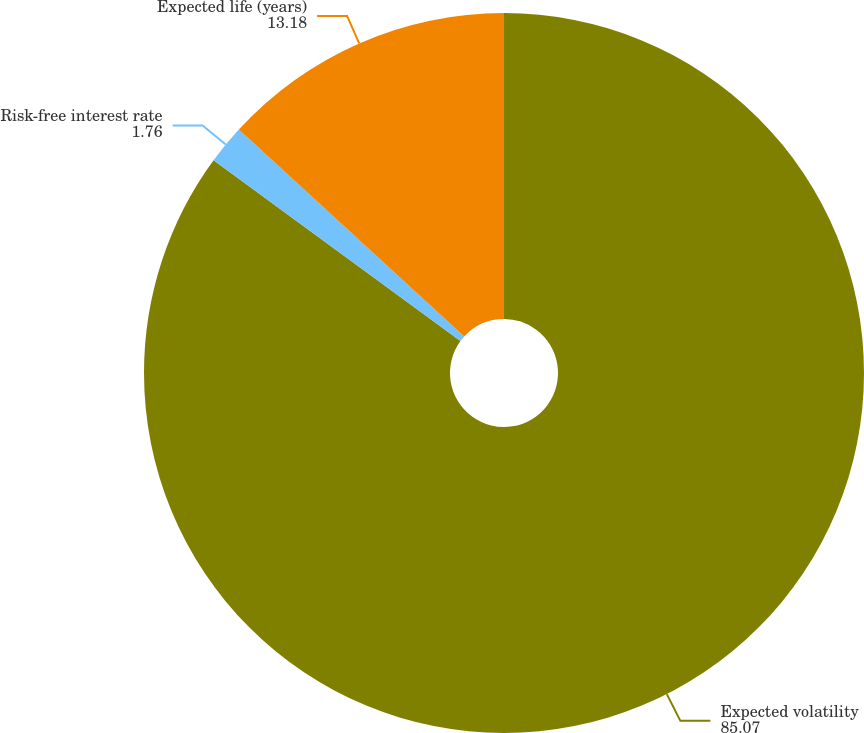Convert chart to OTSL. <chart><loc_0><loc_0><loc_500><loc_500><pie_chart><fcel>Expected volatility<fcel>Risk-free interest rate<fcel>Expected life (years)<nl><fcel>85.07%<fcel>1.76%<fcel>13.18%<nl></chart> 